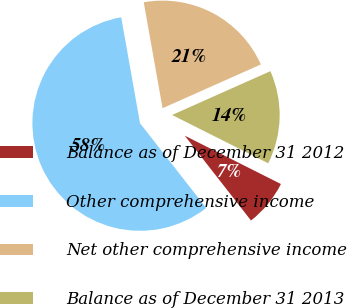Convert chart. <chart><loc_0><loc_0><loc_500><loc_500><pie_chart><fcel>Balance as of December 31 2012<fcel>Other comprehensive income<fcel>Net other comprehensive income<fcel>Balance as of December 31 2013<nl><fcel>7.04%<fcel>57.75%<fcel>21.13%<fcel>14.08%<nl></chart> 